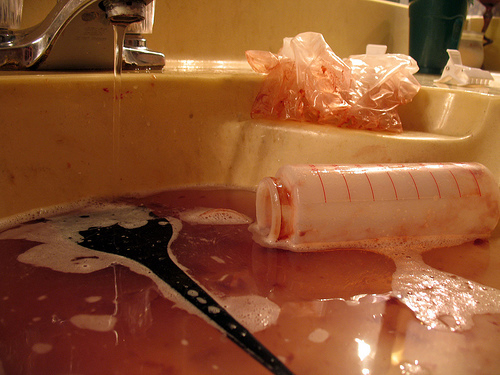<image>
Is there a bottle next to the sink? No. The bottle is not positioned next to the sink. They are located in different areas of the scene. 